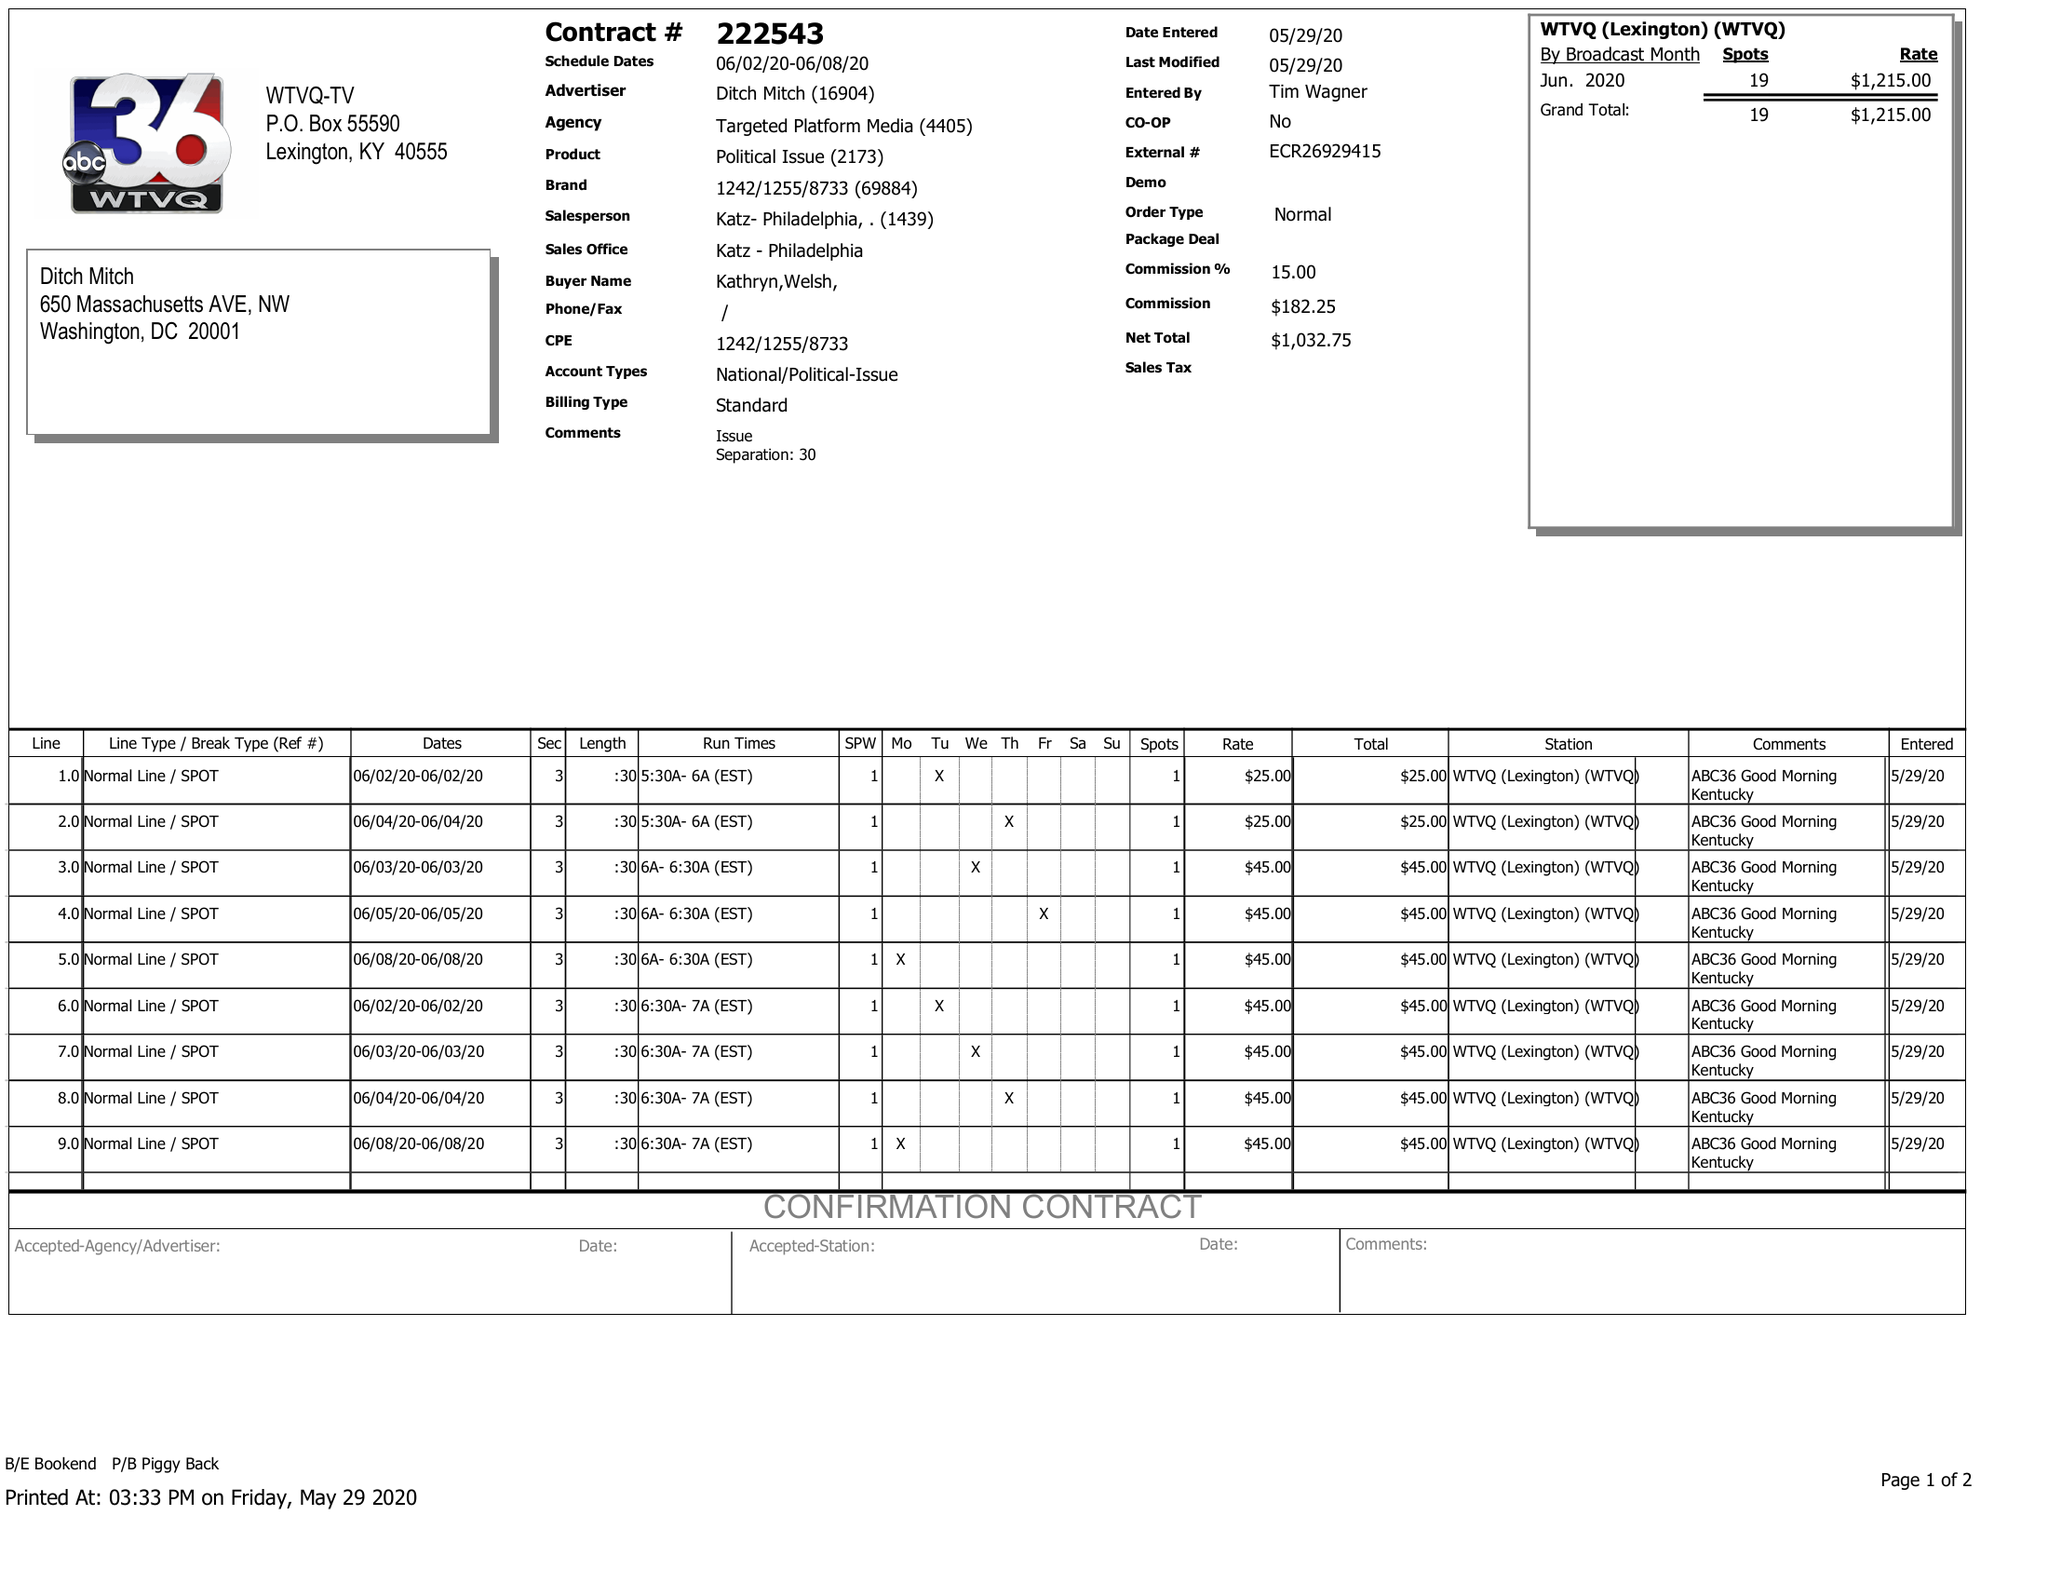What is the value for the advertiser?
Answer the question using a single word or phrase. DITCH MITCH 